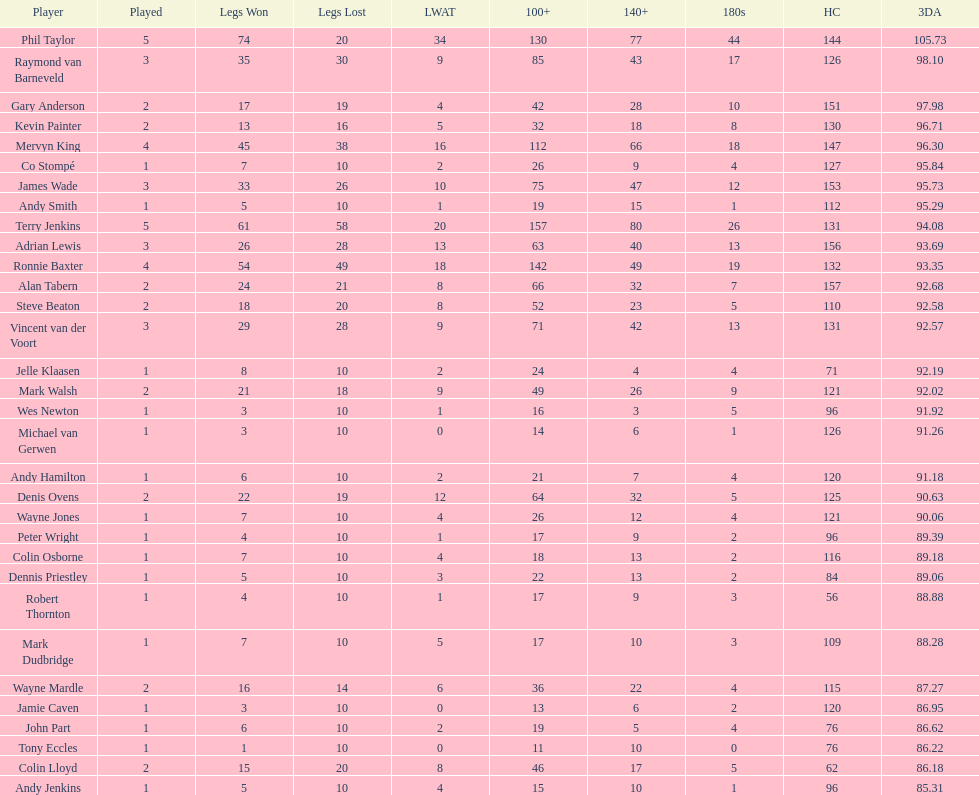How many players have a 3 dart average of more than 97? 3. 